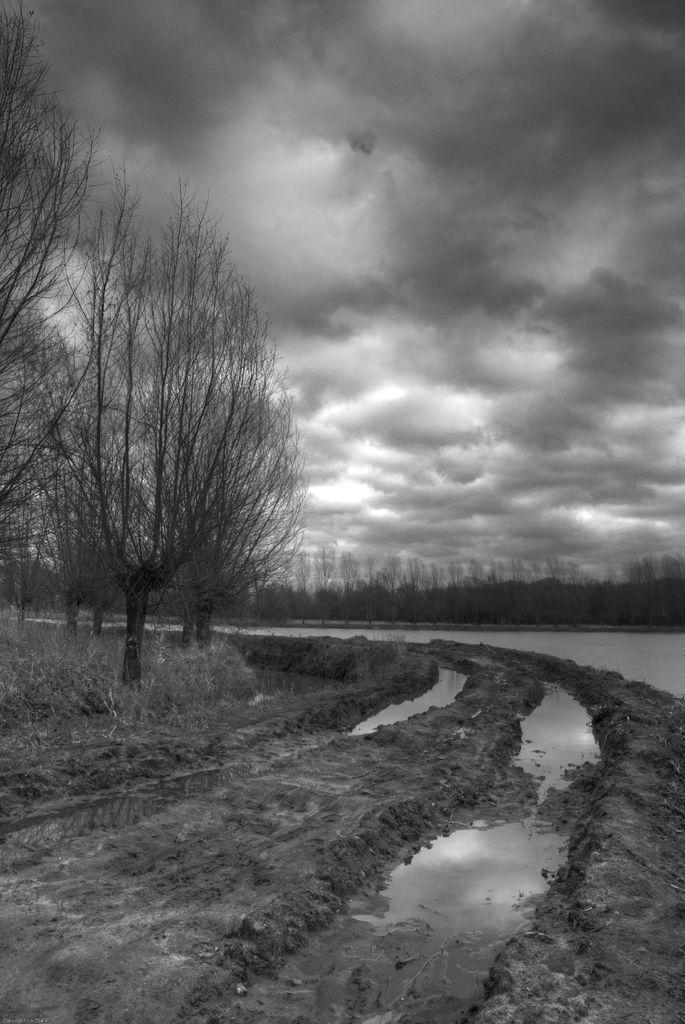What is the color scheme of the image? The image is monochrome. What type of natural elements can be seen in the image? There are trees in the image. What body of water is visible in the image? There is water visible in the image. What type of man-made structure is present in the image? There is a road in the image. How does the wire affect the trees in the image? There is no wire present in the image, so it does not affect the trees. 